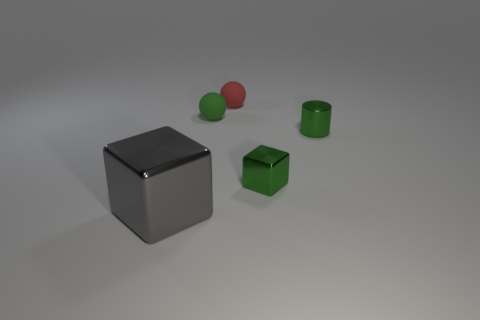Add 4 small green balls. How many objects exist? 9 Subtract all balls. How many objects are left? 3 Add 4 tiny metal things. How many tiny metal things exist? 6 Subtract 0 brown spheres. How many objects are left? 5 Subtract all large gray objects. Subtract all tiny red balls. How many objects are left? 3 Add 1 green blocks. How many green blocks are left? 2 